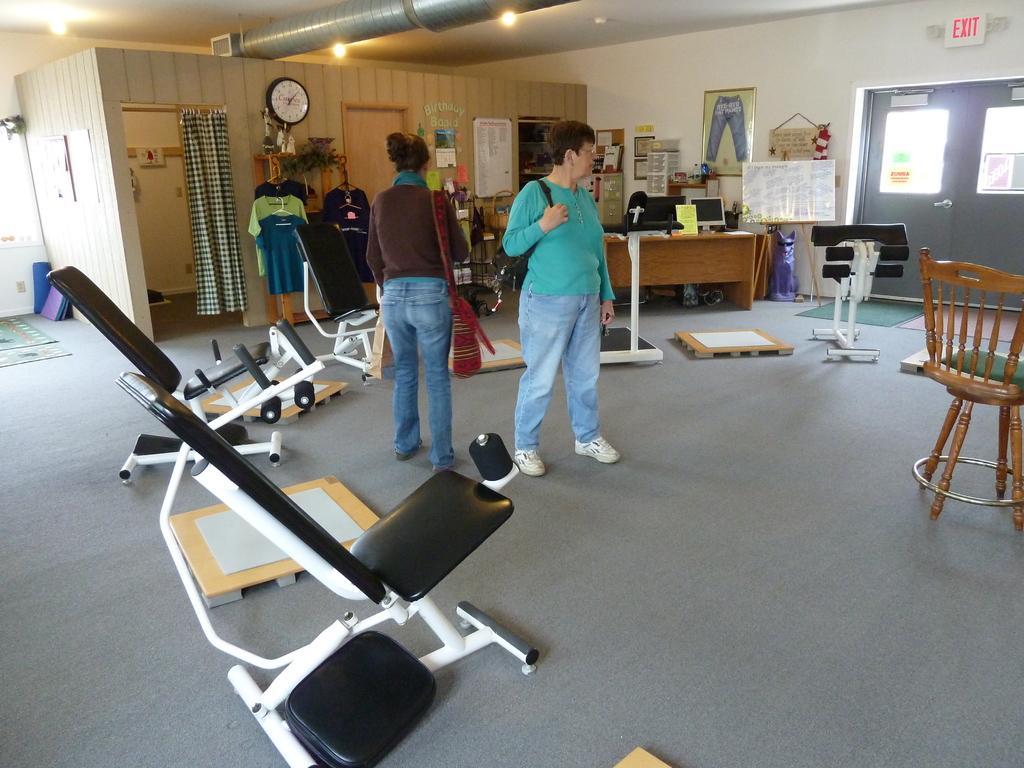In one or two sentences, can you explain what this image depicts? There are two persons standing on the floor. Here we can see a chair, table, monitor, board, clothes, curtain, door, frames, and a clock. This is floor. There are lights and this is wall. 